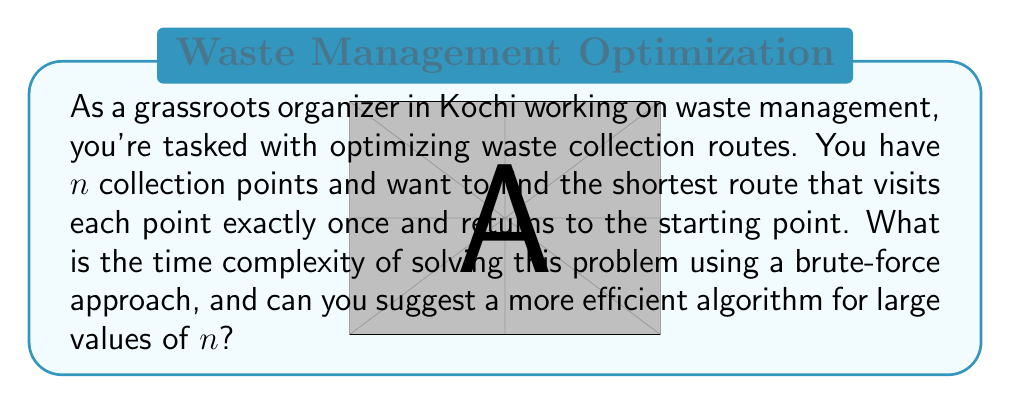Give your solution to this math problem. This problem is known as the Traveling Salesman Problem (TSP) in computational complexity theory. Let's analyze it step by step:

1. Brute-force approach:
   - Generate all possible permutations of $n$ collection points: $n!$
   - For each permutation, calculate the total distance: $O(n)$
   - Time complexity: $O(n! \cdot n) = O(n \cdot n!)$

2. Why this is inefficient:
   - For large $n$, $n!$ grows extremely fast
   - Example: for $n = 20$, $20! \approx 2.43 \times 10^{18}$ permutations

3. More efficient algorithms:
   a) Dynamic Programming (Held-Karp algorithm):
      - Time complexity: $O(n^2 \cdot 2^n)$
      - While still exponential, it's much faster than brute-force for large $n$

   b) Approximation algorithms:
      - Christofides algorithm: $O(n^3)$ time complexity
      - Guarantees a solution within 1.5 times the optimal solution

   c) Heuristic algorithms:
      - Nearest Neighbor: $O(n^2)$ time complexity
      - 2-Opt: $O(n^2)$ per iteration
      - These don't guarantee optimal solutions but can be very fast

For waste collection in Kochi, where $n$ might be in the hundreds or thousands, approximation or heuristic algorithms would be more practical. They provide good solutions in reasonable time, which is crucial for day-to-day operations.
Answer: The time complexity of the brute-force approach is $O(n \cdot n!)$. For large $n$, more efficient algorithms like the Held-Karp algorithm with $O(n^2 \cdot 2^n)$ complexity, or approximation algorithms like Christofides with $O(n^3)$ complexity, are recommended. 